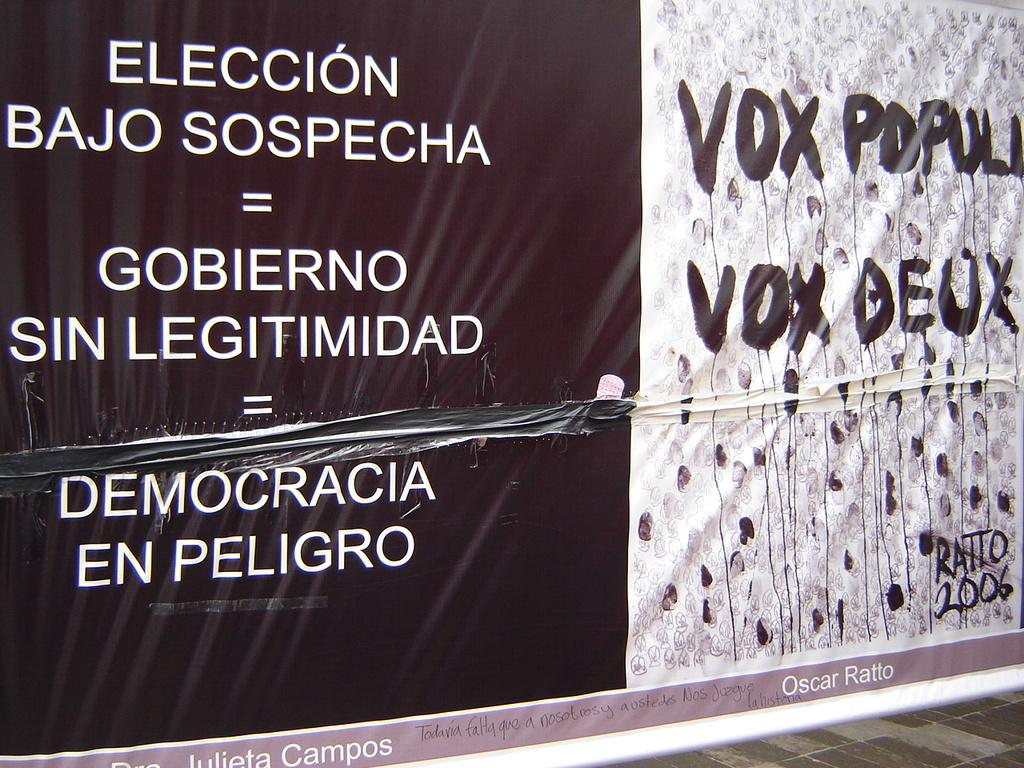<image>
Provide a brief description of the given image. A large black and white billboard with Vox Populi on it. 